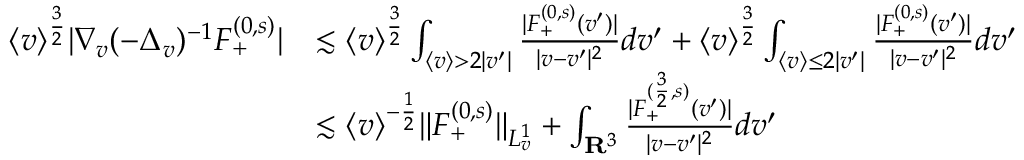Convert formula to latex. <formula><loc_0><loc_0><loc_500><loc_500>\begin{array} { r l } { \langle v \rangle ^ { \frac { 3 } { 2 } } | \nabla _ { v } ( - \Delta _ { v } ) ^ { - 1 } F _ { + } ^ { ( 0 , s ) } | } & { \lesssim \langle v \rangle ^ { \frac { 3 } { 2 } } \int _ { \langle v \rangle > 2 | v ^ { \prime } | } \frac { | F _ { + } ^ { ( 0 , s ) } ( v ^ { \prime } ) | } { | v - v ^ { \prime } | ^ { 2 } } d v ^ { \prime } + \langle v \rangle ^ { \frac { 3 } { 2 } } \int _ { \langle v \rangle \leq 2 | v ^ { \prime } | } \frac { | F _ { + } ^ { ( 0 , s ) } ( v ^ { \prime } ) | } { | v - v ^ { \prime } | ^ { 2 } } d v ^ { \prime } } \\ & { \lesssim \langle v \rangle ^ { - \frac { 1 } { 2 } } \| F _ { + } ^ { ( 0 , s ) } \| _ { L _ { v } ^ { 1 } } + \int _ { \mathbf R ^ { 3 } } \frac { | F _ { + } ^ { ( \frac { 3 } { 2 } , s ) } ( v ^ { \prime } ) | } { | v - v ^ { \prime } | ^ { 2 } } d v ^ { \prime } } \end{array}</formula> 